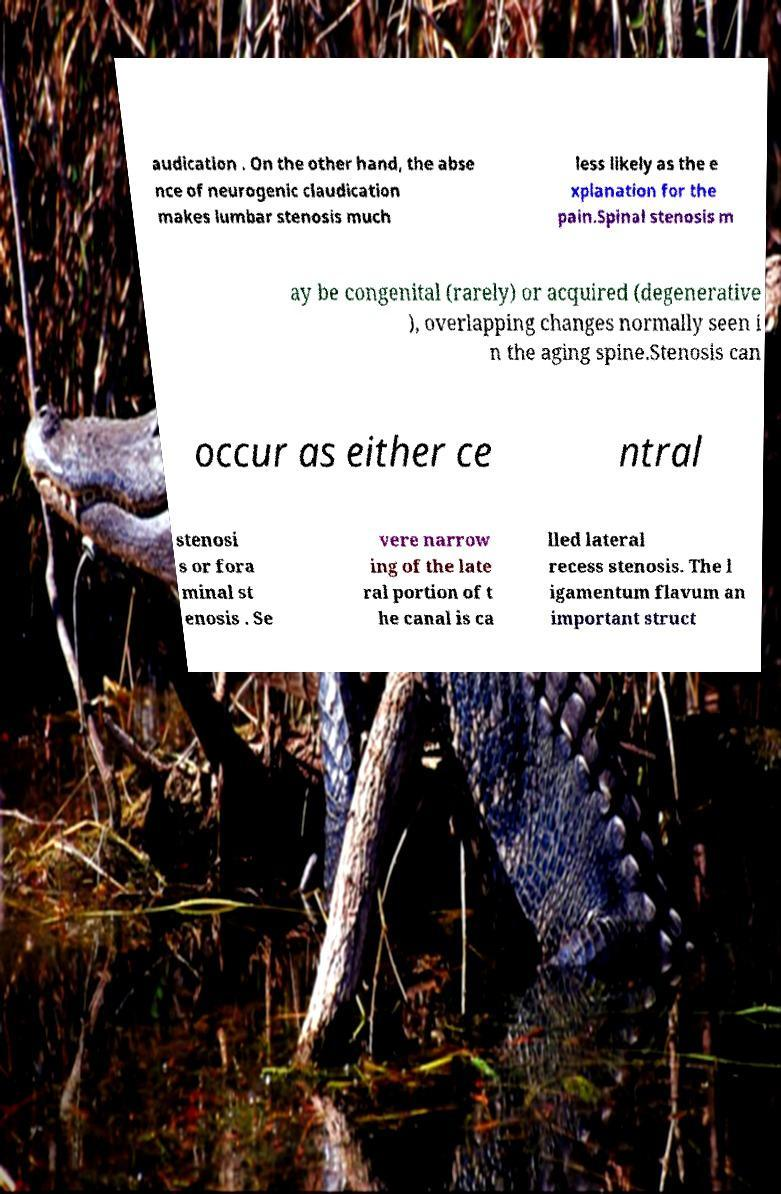Could you extract and type out the text from this image? audication . On the other hand, the abse nce of neurogenic claudication makes lumbar stenosis much less likely as the e xplanation for the pain.Spinal stenosis m ay be congenital (rarely) or acquired (degenerative ), overlapping changes normally seen i n the aging spine.Stenosis can occur as either ce ntral stenosi s or fora minal st enosis . Se vere narrow ing of the late ral portion of t he canal is ca lled lateral recess stenosis. The l igamentum flavum an important struct 